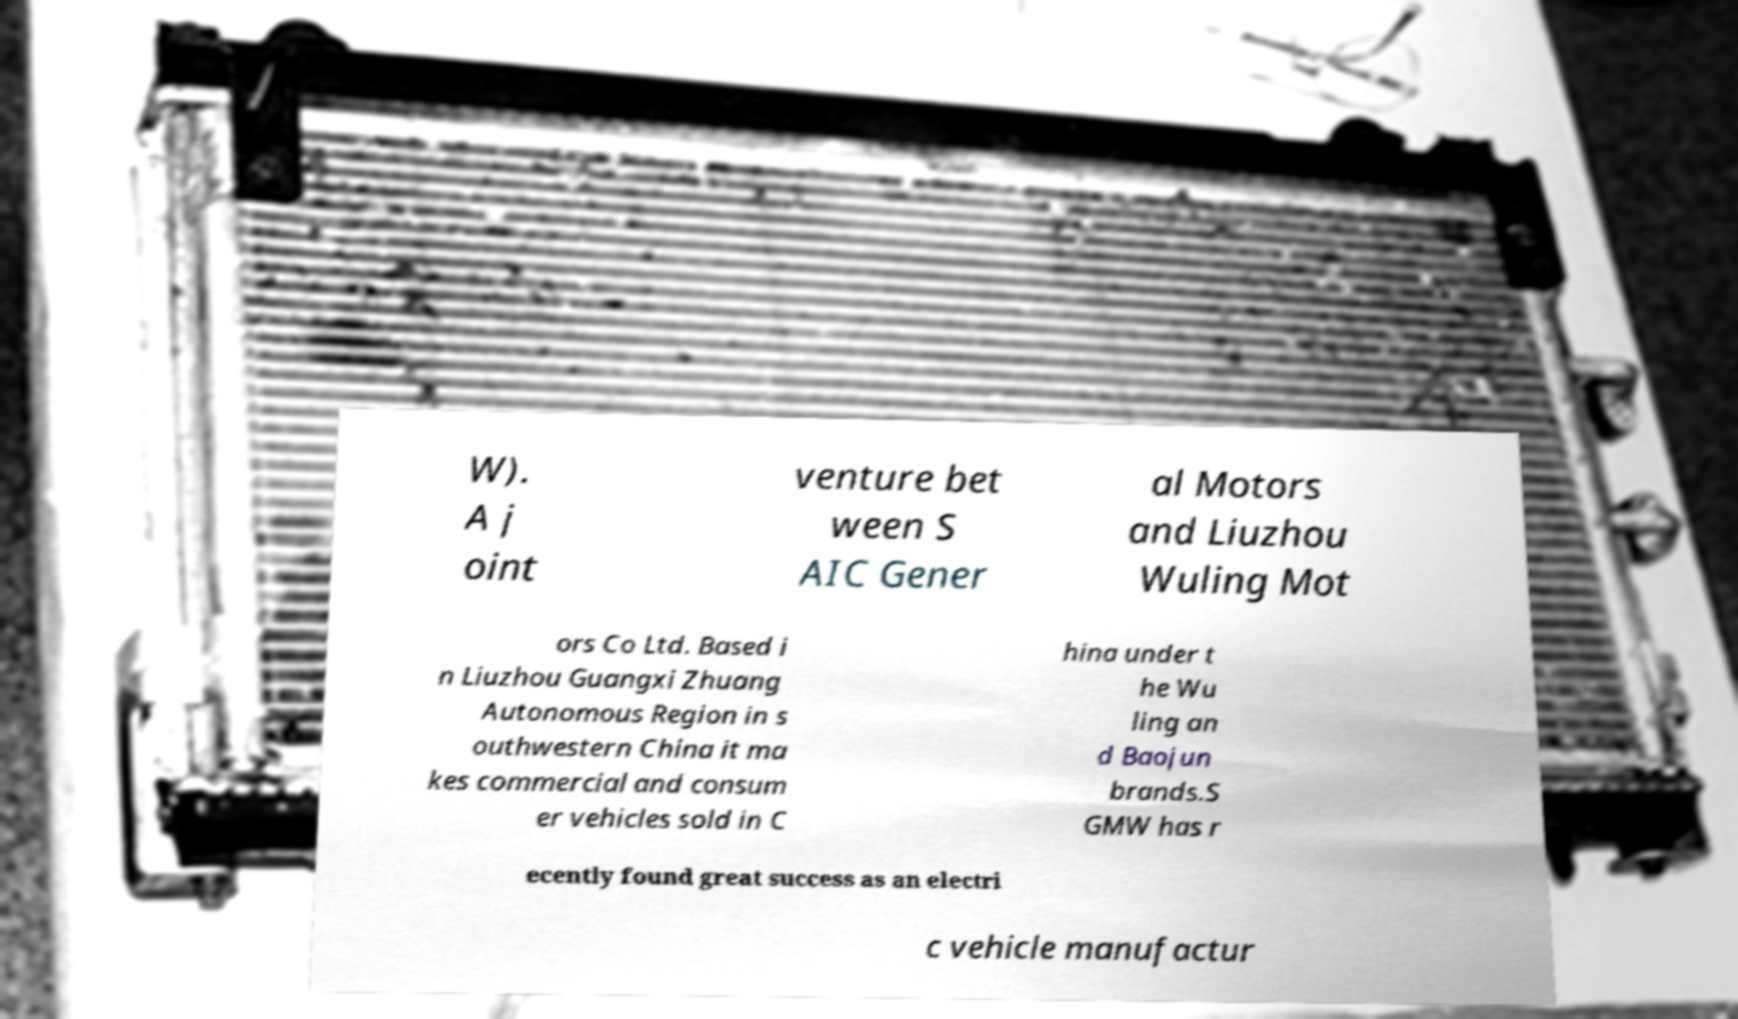For documentation purposes, I need the text within this image transcribed. Could you provide that? W). A j oint venture bet ween S AIC Gener al Motors and Liuzhou Wuling Mot ors Co Ltd. Based i n Liuzhou Guangxi Zhuang Autonomous Region in s outhwestern China it ma kes commercial and consum er vehicles sold in C hina under t he Wu ling an d Baojun brands.S GMW has r ecently found great success as an electri c vehicle manufactur 